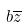Convert formula to latex. <formula><loc_0><loc_0><loc_500><loc_500>b \overline { z }</formula> 